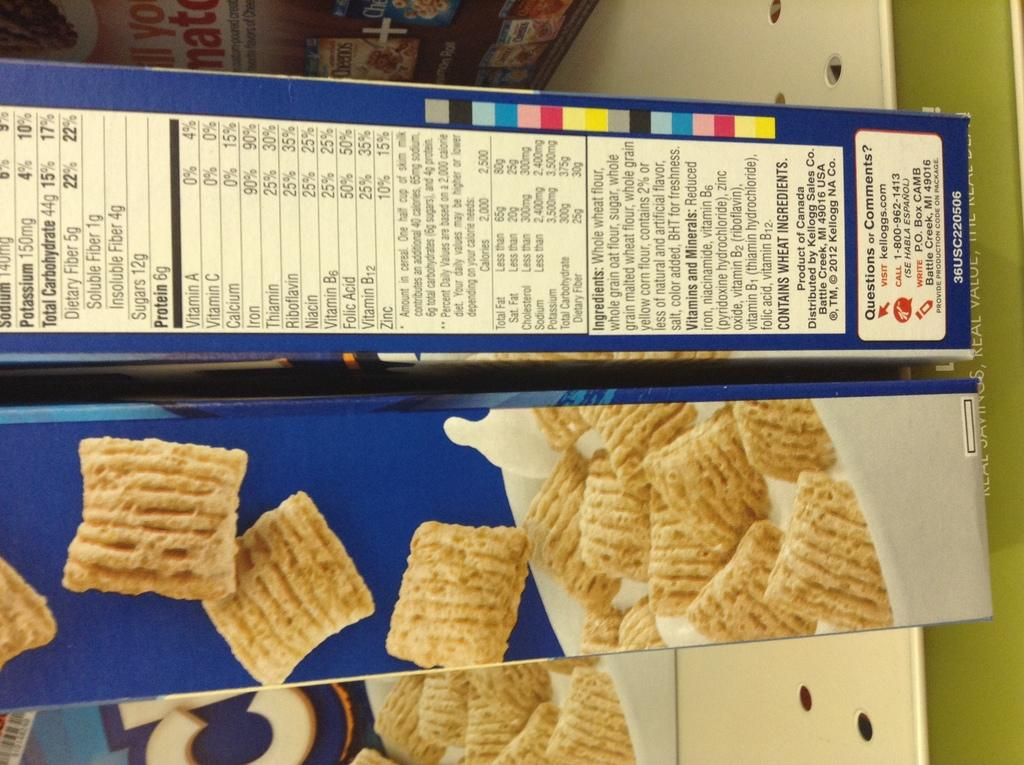What is located in the middle of the image? There are food item boxes in the middle of the image. What can be seen at the bottom of the image? There are images of food at the bottom of the image. Where is the text located in the image? The text is at the top of the image. How does the eggnog contribute to the pollution in the image? There is no eggnog or pollution present in the image. What type of mitten is being used to handle the food items in the image? There are no mittens present in the image; it only features food item boxes, images of food, and text. 